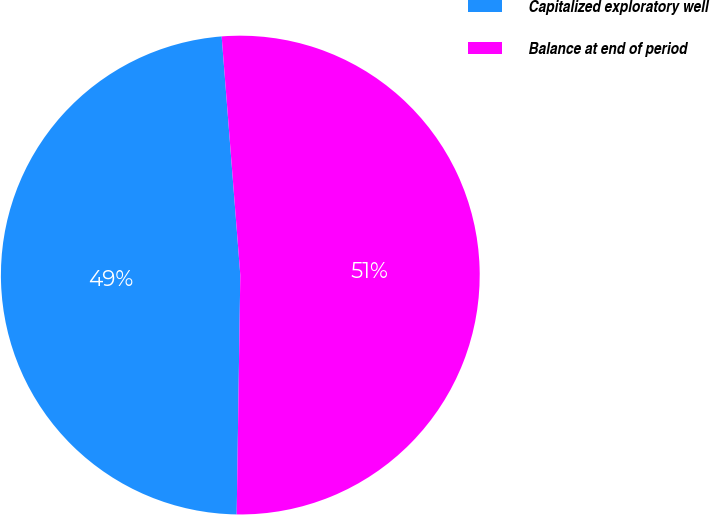Convert chart to OTSL. <chart><loc_0><loc_0><loc_500><loc_500><pie_chart><fcel>Capitalized exploratory well<fcel>Balance at end of period<nl><fcel>48.52%<fcel>51.48%<nl></chart> 